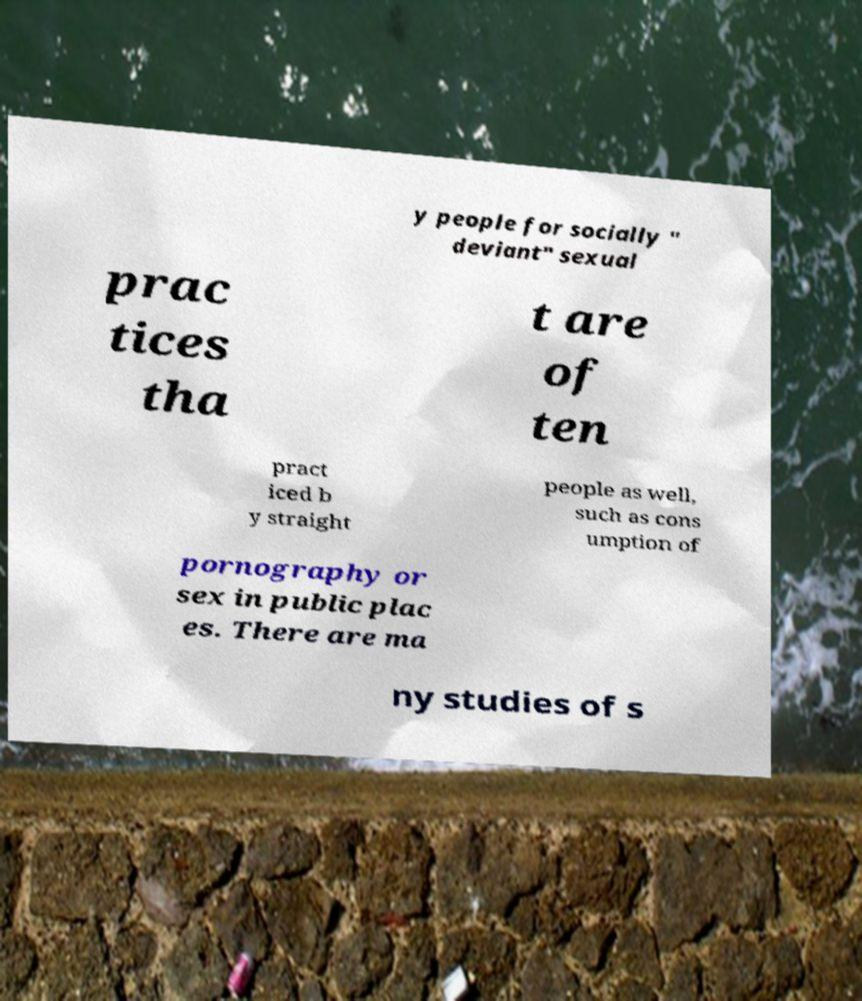There's text embedded in this image that I need extracted. Can you transcribe it verbatim? y people for socially " deviant" sexual prac tices tha t are of ten pract iced b y straight people as well, such as cons umption of pornography or sex in public plac es. There are ma ny studies of s 